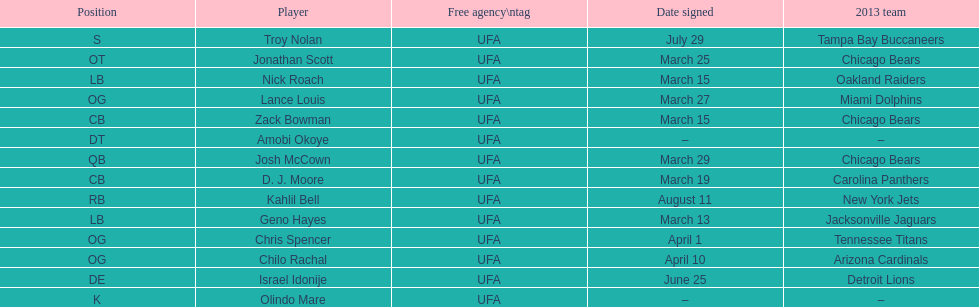How many players play cb or og? 5. 